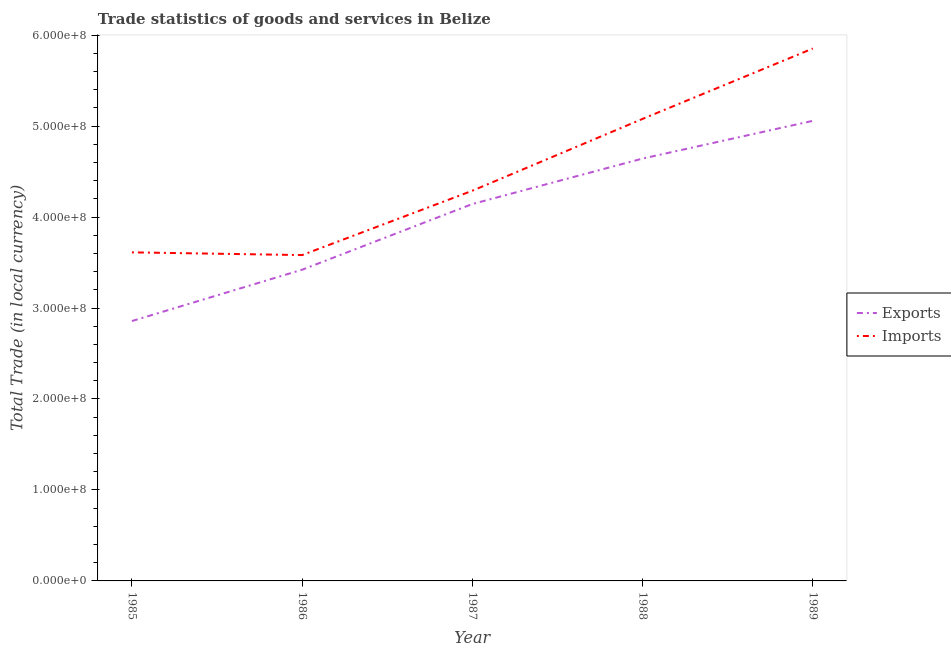What is the export of goods and services in 1987?
Offer a terse response. 4.14e+08. Across all years, what is the maximum imports of goods and services?
Offer a terse response. 5.85e+08. Across all years, what is the minimum imports of goods and services?
Provide a succinct answer. 3.58e+08. In which year was the imports of goods and services maximum?
Offer a very short reply. 1989. In which year was the export of goods and services minimum?
Your answer should be very brief. 1985. What is the total imports of goods and services in the graph?
Give a very brief answer. 2.24e+09. What is the difference between the export of goods and services in 1986 and that in 1989?
Your response must be concise. -1.64e+08. What is the difference between the imports of goods and services in 1989 and the export of goods and services in 1988?
Provide a short and direct response. 1.21e+08. What is the average imports of goods and services per year?
Ensure brevity in your answer.  4.48e+08. In the year 1988, what is the difference between the imports of goods and services and export of goods and services?
Make the answer very short. 4.36e+07. What is the ratio of the export of goods and services in 1986 to that in 1987?
Ensure brevity in your answer.  0.83. What is the difference between the highest and the second highest imports of goods and services?
Provide a short and direct response. 7.74e+07. What is the difference between the highest and the lowest export of goods and services?
Offer a very short reply. 2.20e+08. In how many years, is the export of goods and services greater than the average export of goods and services taken over all years?
Keep it short and to the point. 3. Is the sum of the export of goods and services in 1985 and 1988 greater than the maximum imports of goods and services across all years?
Give a very brief answer. Yes. Does the imports of goods and services monotonically increase over the years?
Your response must be concise. No. How many lines are there?
Ensure brevity in your answer.  2. How many years are there in the graph?
Give a very brief answer. 5. Does the graph contain any zero values?
Your response must be concise. No. Where does the legend appear in the graph?
Ensure brevity in your answer.  Center right. How are the legend labels stacked?
Provide a succinct answer. Vertical. What is the title of the graph?
Your answer should be very brief. Trade statistics of goods and services in Belize. Does "Non-pregnant women" appear as one of the legend labels in the graph?
Provide a succinct answer. No. What is the label or title of the X-axis?
Provide a succinct answer. Year. What is the label or title of the Y-axis?
Ensure brevity in your answer.  Total Trade (in local currency). What is the Total Trade (in local currency) of Exports in 1985?
Make the answer very short. 2.86e+08. What is the Total Trade (in local currency) of Imports in 1985?
Give a very brief answer. 3.61e+08. What is the Total Trade (in local currency) of Exports in 1986?
Provide a short and direct response. 3.42e+08. What is the Total Trade (in local currency) in Imports in 1986?
Make the answer very short. 3.58e+08. What is the Total Trade (in local currency) of Exports in 1987?
Keep it short and to the point. 4.14e+08. What is the Total Trade (in local currency) in Imports in 1987?
Offer a terse response. 4.29e+08. What is the Total Trade (in local currency) in Exports in 1988?
Your response must be concise. 4.64e+08. What is the Total Trade (in local currency) of Imports in 1988?
Provide a short and direct response. 5.08e+08. What is the Total Trade (in local currency) in Exports in 1989?
Offer a very short reply. 5.06e+08. What is the Total Trade (in local currency) in Imports in 1989?
Your answer should be very brief. 5.85e+08. Across all years, what is the maximum Total Trade (in local currency) of Exports?
Offer a terse response. 5.06e+08. Across all years, what is the maximum Total Trade (in local currency) of Imports?
Your answer should be very brief. 5.85e+08. Across all years, what is the minimum Total Trade (in local currency) in Exports?
Provide a succinct answer. 2.86e+08. Across all years, what is the minimum Total Trade (in local currency) in Imports?
Your answer should be very brief. 3.58e+08. What is the total Total Trade (in local currency) of Exports in the graph?
Ensure brevity in your answer.  2.01e+09. What is the total Total Trade (in local currency) of Imports in the graph?
Make the answer very short. 2.24e+09. What is the difference between the Total Trade (in local currency) in Exports in 1985 and that in 1986?
Provide a short and direct response. -5.64e+07. What is the difference between the Total Trade (in local currency) in Imports in 1985 and that in 1986?
Provide a short and direct response. 2.98e+06. What is the difference between the Total Trade (in local currency) in Exports in 1985 and that in 1987?
Your answer should be very brief. -1.29e+08. What is the difference between the Total Trade (in local currency) of Imports in 1985 and that in 1987?
Your answer should be very brief. -6.78e+07. What is the difference between the Total Trade (in local currency) in Exports in 1985 and that in 1988?
Your answer should be compact. -1.79e+08. What is the difference between the Total Trade (in local currency) in Imports in 1985 and that in 1988?
Your answer should be compact. -1.47e+08. What is the difference between the Total Trade (in local currency) of Exports in 1985 and that in 1989?
Offer a terse response. -2.20e+08. What is the difference between the Total Trade (in local currency) of Imports in 1985 and that in 1989?
Keep it short and to the point. -2.24e+08. What is the difference between the Total Trade (in local currency) of Exports in 1986 and that in 1987?
Your answer should be compact. -7.22e+07. What is the difference between the Total Trade (in local currency) of Imports in 1986 and that in 1987?
Make the answer very short. -7.08e+07. What is the difference between the Total Trade (in local currency) of Exports in 1986 and that in 1988?
Keep it short and to the point. -1.22e+08. What is the difference between the Total Trade (in local currency) in Imports in 1986 and that in 1988?
Provide a short and direct response. -1.50e+08. What is the difference between the Total Trade (in local currency) of Exports in 1986 and that in 1989?
Give a very brief answer. -1.64e+08. What is the difference between the Total Trade (in local currency) in Imports in 1986 and that in 1989?
Give a very brief answer. -2.27e+08. What is the difference between the Total Trade (in local currency) in Exports in 1987 and that in 1988?
Give a very brief answer. -5.00e+07. What is the difference between the Total Trade (in local currency) of Imports in 1987 and that in 1988?
Provide a short and direct response. -7.90e+07. What is the difference between the Total Trade (in local currency) of Exports in 1987 and that in 1989?
Keep it short and to the point. -9.14e+07. What is the difference between the Total Trade (in local currency) in Imports in 1987 and that in 1989?
Keep it short and to the point. -1.56e+08. What is the difference between the Total Trade (in local currency) of Exports in 1988 and that in 1989?
Your answer should be very brief. -4.15e+07. What is the difference between the Total Trade (in local currency) in Imports in 1988 and that in 1989?
Make the answer very short. -7.74e+07. What is the difference between the Total Trade (in local currency) in Exports in 1985 and the Total Trade (in local currency) in Imports in 1986?
Give a very brief answer. -7.25e+07. What is the difference between the Total Trade (in local currency) in Exports in 1985 and the Total Trade (in local currency) in Imports in 1987?
Your response must be concise. -1.43e+08. What is the difference between the Total Trade (in local currency) in Exports in 1985 and the Total Trade (in local currency) in Imports in 1988?
Give a very brief answer. -2.22e+08. What is the difference between the Total Trade (in local currency) of Exports in 1985 and the Total Trade (in local currency) of Imports in 1989?
Keep it short and to the point. -3.00e+08. What is the difference between the Total Trade (in local currency) in Exports in 1986 and the Total Trade (in local currency) in Imports in 1987?
Your answer should be very brief. -8.68e+07. What is the difference between the Total Trade (in local currency) of Exports in 1986 and the Total Trade (in local currency) of Imports in 1988?
Provide a succinct answer. -1.66e+08. What is the difference between the Total Trade (in local currency) of Exports in 1986 and the Total Trade (in local currency) of Imports in 1989?
Give a very brief answer. -2.43e+08. What is the difference between the Total Trade (in local currency) of Exports in 1987 and the Total Trade (in local currency) of Imports in 1988?
Your response must be concise. -9.36e+07. What is the difference between the Total Trade (in local currency) of Exports in 1987 and the Total Trade (in local currency) of Imports in 1989?
Your answer should be compact. -1.71e+08. What is the difference between the Total Trade (in local currency) of Exports in 1988 and the Total Trade (in local currency) of Imports in 1989?
Offer a very short reply. -1.21e+08. What is the average Total Trade (in local currency) of Exports per year?
Give a very brief answer. 4.02e+08. What is the average Total Trade (in local currency) of Imports per year?
Make the answer very short. 4.48e+08. In the year 1985, what is the difference between the Total Trade (in local currency) of Exports and Total Trade (in local currency) of Imports?
Provide a succinct answer. -7.55e+07. In the year 1986, what is the difference between the Total Trade (in local currency) of Exports and Total Trade (in local currency) of Imports?
Give a very brief answer. -1.61e+07. In the year 1987, what is the difference between the Total Trade (in local currency) of Exports and Total Trade (in local currency) of Imports?
Offer a very short reply. -1.46e+07. In the year 1988, what is the difference between the Total Trade (in local currency) of Exports and Total Trade (in local currency) of Imports?
Give a very brief answer. -4.36e+07. In the year 1989, what is the difference between the Total Trade (in local currency) of Exports and Total Trade (in local currency) of Imports?
Your answer should be very brief. -7.95e+07. What is the ratio of the Total Trade (in local currency) of Exports in 1985 to that in 1986?
Your response must be concise. 0.84. What is the ratio of the Total Trade (in local currency) of Imports in 1985 to that in 1986?
Keep it short and to the point. 1.01. What is the ratio of the Total Trade (in local currency) in Exports in 1985 to that in 1987?
Ensure brevity in your answer.  0.69. What is the ratio of the Total Trade (in local currency) in Imports in 1985 to that in 1987?
Provide a succinct answer. 0.84. What is the ratio of the Total Trade (in local currency) of Exports in 1985 to that in 1988?
Ensure brevity in your answer.  0.62. What is the ratio of the Total Trade (in local currency) in Imports in 1985 to that in 1988?
Keep it short and to the point. 0.71. What is the ratio of the Total Trade (in local currency) of Exports in 1985 to that in 1989?
Offer a terse response. 0.56. What is the ratio of the Total Trade (in local currency) of Imports in 1985 to that in 1989?
Provide a succinct answer. 0.62. What is the ratio of the Total Trade (in local currency) of Exports in 1986 to that in 1987?
Provide a succinct answer. 0.83. What is the ratio of the Total Trade (in local currency) in Imports in 1986 to that in 1987?
Provide a succinct answer. 0.84. What is the ratio of the Total Trade (in local currency) of Exports in 1986 to that in 1988?
Give a very brief answer. 0.74. What is the ratio of the Total Trade (in local currency) of Imports in 1986 to that in 1988?
Offer a very short reply. 0.71. What is the ratio of the Total Trade (in local currency) of Exports in 1986 to that in 1989?
Offer a terse response. 0.68. What is the ratio of the Total Trade (in local currency) in Imports in 1986 to that in 1989?
Keep it short and to the point. 0.61. What is the ratio of the Total Trade (in local currency) in Exports in 1987 to that in 1988?
Give a very brief answer. 0.89. What is the ratio of the Total Trade (in local currency) in Imports in 1987 to that in 1988?
Make the answer very short. 0.84. What is the ratio of the Total Trade (in local currency) in Exports in 1987 to that in 1989?
Your response must be concise. 0.82. What is the ratio of the Total Trade (in local currency) of Imports in 1987 to that in 1989?
Ensure brevity in your answer.  0.73. What is the ratio of the Total Trade (in local currency) in Exports in 1988 to that in 1989?
Ensure brevity in your answer.  0.92. What is the ratio of the Total Trade (in local currency) of Imports in 1988 to that in 1989?
Make the answer very short. 0.87. What is the difference between the highest and the second highest Total Trade (in local currency) of Exports?
Offer a terse response. 4.15e+07. What is the difference between the highest and the second highest Total Trade (in local currency) in Imports?
Your answer should be very brief. 7.74e+07. What is the difference between the highest and the lowest Total Trade (in local currency) in Exports?
Provide a succinct answer. 2.20e+08. What is the difference between the highest and the lowest Total Trade (in local currency) in Imports?
Your answer should be very brief. 2.27e+08. 